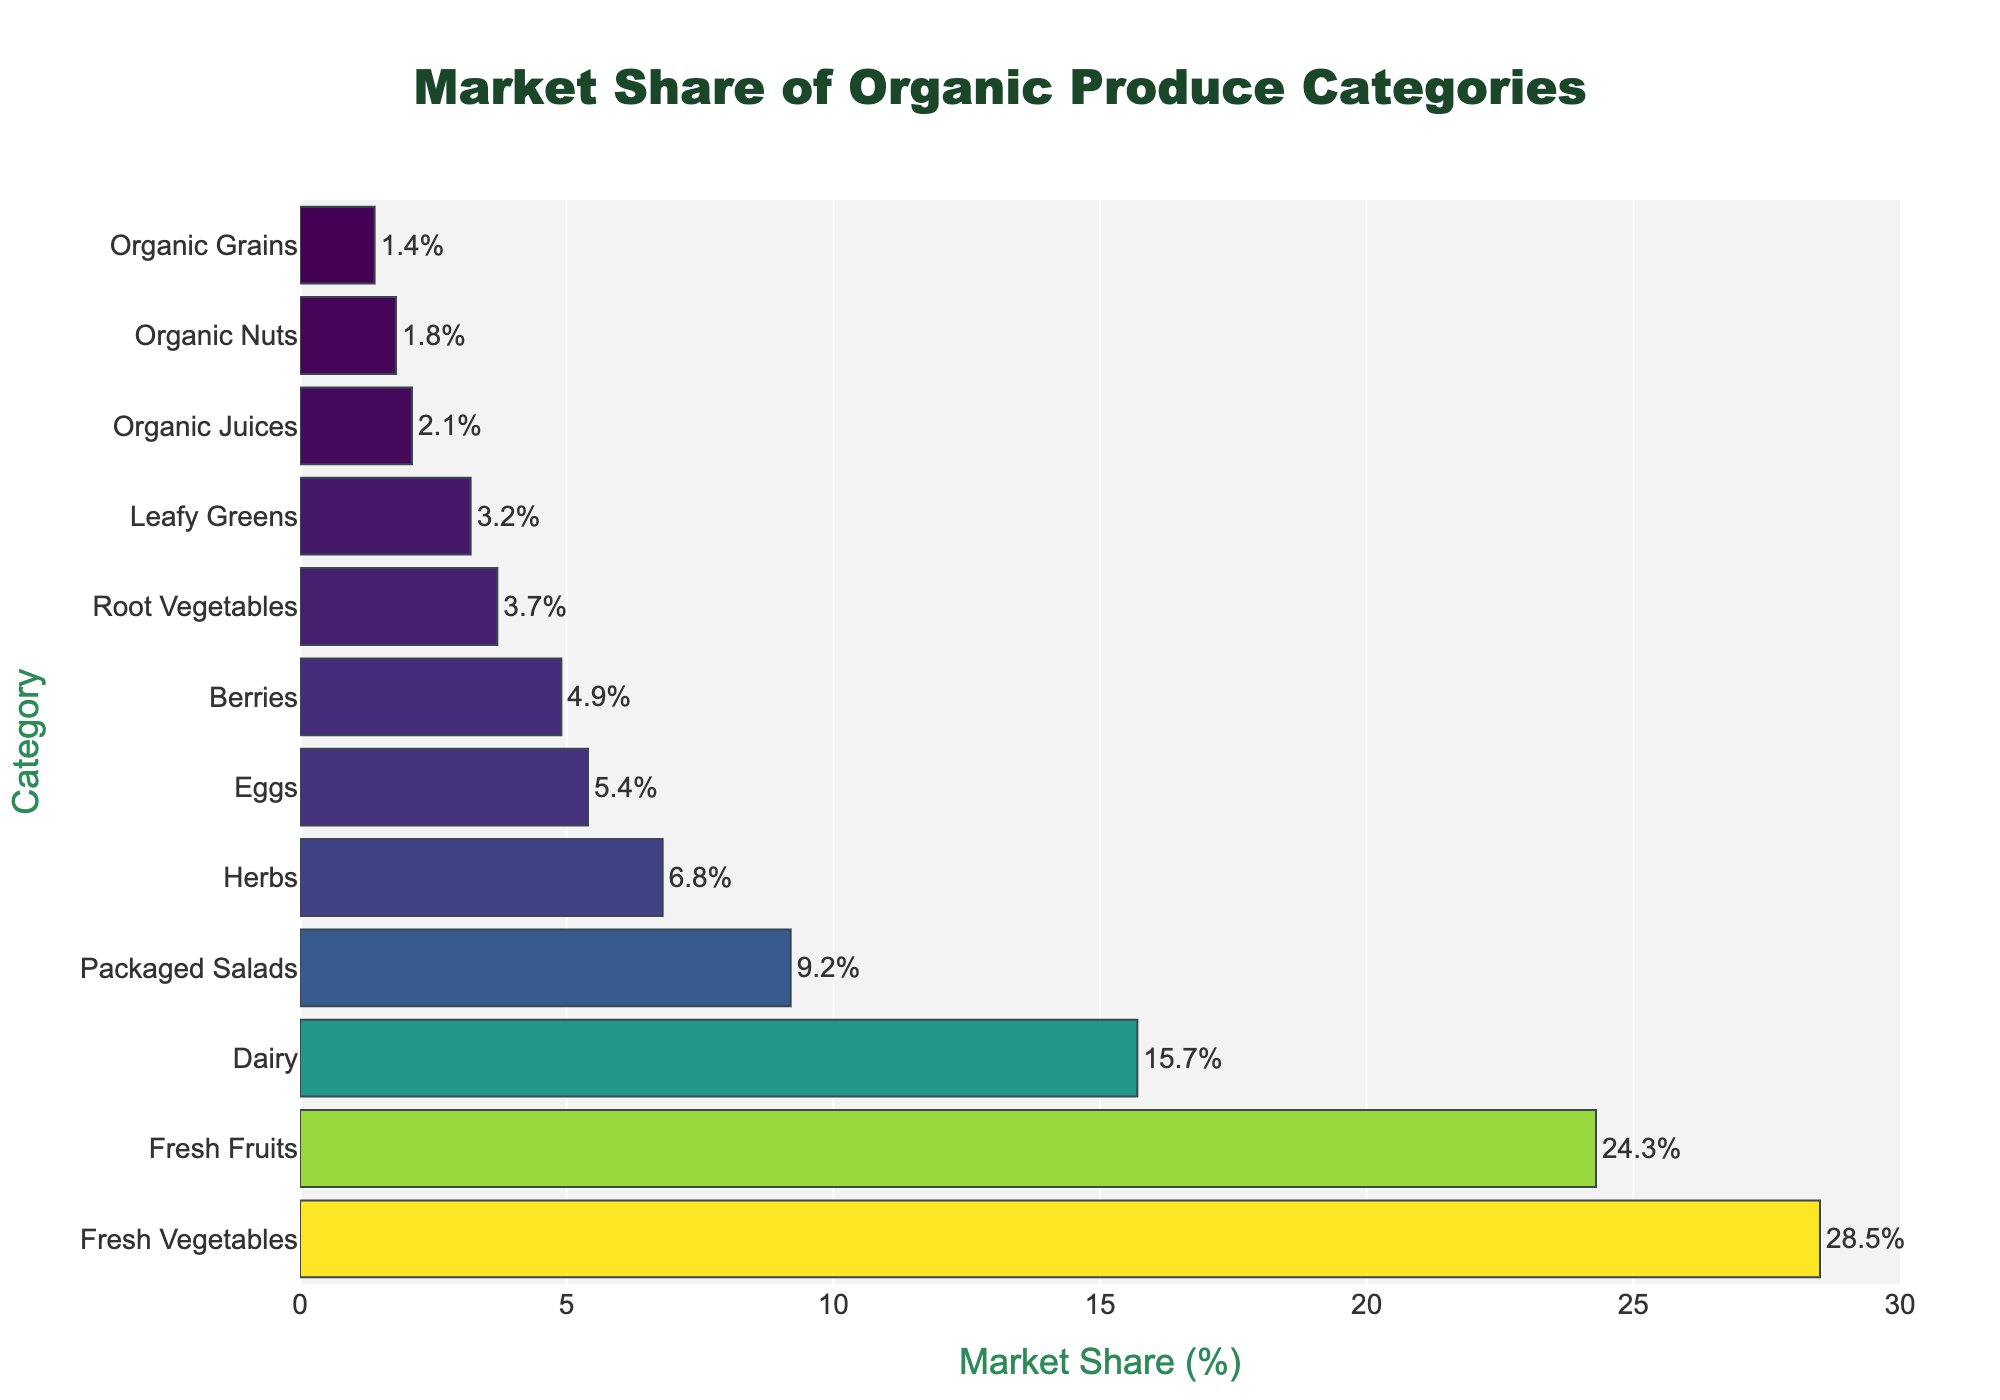Which organic produce category has the highest market share? From the bar chart, the category with the longest bar corresponds to Fresh Vegetables, which also has the highest percentage of 28.5%.
Answer: Fresh Vegetables What is the total market share of Fresh Vegetables and Fresh Fruits combined? Add the market shares of Fresh Vegetables (28.5%) and Fresh Fruits (24.3%) to get the total. 28.5% + 24.3% = 52.8%.
Answer: 52.8% Which category has a market share just below 10%? Referring to the bars that lengthwise represent the market share. The category with a market share just below 10% is Packaged Salads with 9.2%.
Answer: Packaged Salads What is the difference in market share percentages between Dairy and Eggs? Subtract the market share of Eggs from Dairy: 15.7% - 5.4% = 10.3%.
Answer: 10.3% Which category has a higher market share: Herbs or Berries? From the bar chart, Herbs has a share of 6.8% while Berries has 4.9%. Since 6.8% > 4.9%, Herbs has a higher market share.
Answer: Herbs What is the market share range (difference between highest and lowest values) for the categories? The highest market share is Fresh Vegetables at 28.5%, and the lowest is Organic Grains at 1.4%. The range is 28.5% - 1.4% = 27.1%.
Answer: 27.1% How many categories have a market share below 5%? Count the categories with market shares below 5% in the chart. These are Berries (4.9%), Root Vegetables (3.7%), Leafy Greens (3.2%), Organic Juices (2.1%), Organic Nuts (1.8%), and Organic Grains (1.4%). There are 6 categories.
Answer: 6 What is the average market share of Dairy, Eggs, and Berries? First add the market shares of these categories: 15.7% + 5.4% + 4.9% = 26%. Then divide by the number of categories (3). 26% / 3 = 8.67%.
Answer: 8.67% Order the categories with market shares above 10% in descending order. The categories with market shares above 10% are Fresh Vegetables (28.5%), Fresh Fruits (24.3%), and Dairy (15.7%). Ordering them in descending order gives: Fresh Vegetables, Fresh Fruits, Dairy.
Answer: Fresh Vegetables, Fresh Fruits, Dairy What percentage of the market does the lowest three categories combined hold? Sum the market share of the lowest three categories: Leafy Greens (3.2%), Organic Juices (2.1%), and Organic Grains (1.4%). 3.2% + 2.1% + 1.4% = 6.7%.
Answer: 6.7% 